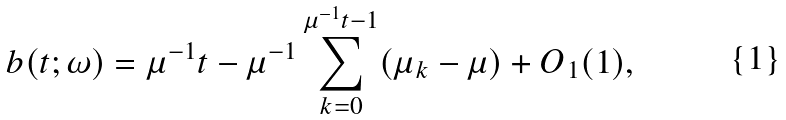Convert formula to latex. <formula><loc_0><loc_0><loc_500><loc_500>b ( t ; \omega ) = \mu ^ { - 1 } t - \mu ^ { - 1 } \sum _ { k = 0 } ^ { \mu ^ { - 1 } t - 1 } ( \mu _ { k } - \mu ) + O _ { 1 } ( 1 ) ,</formula> 